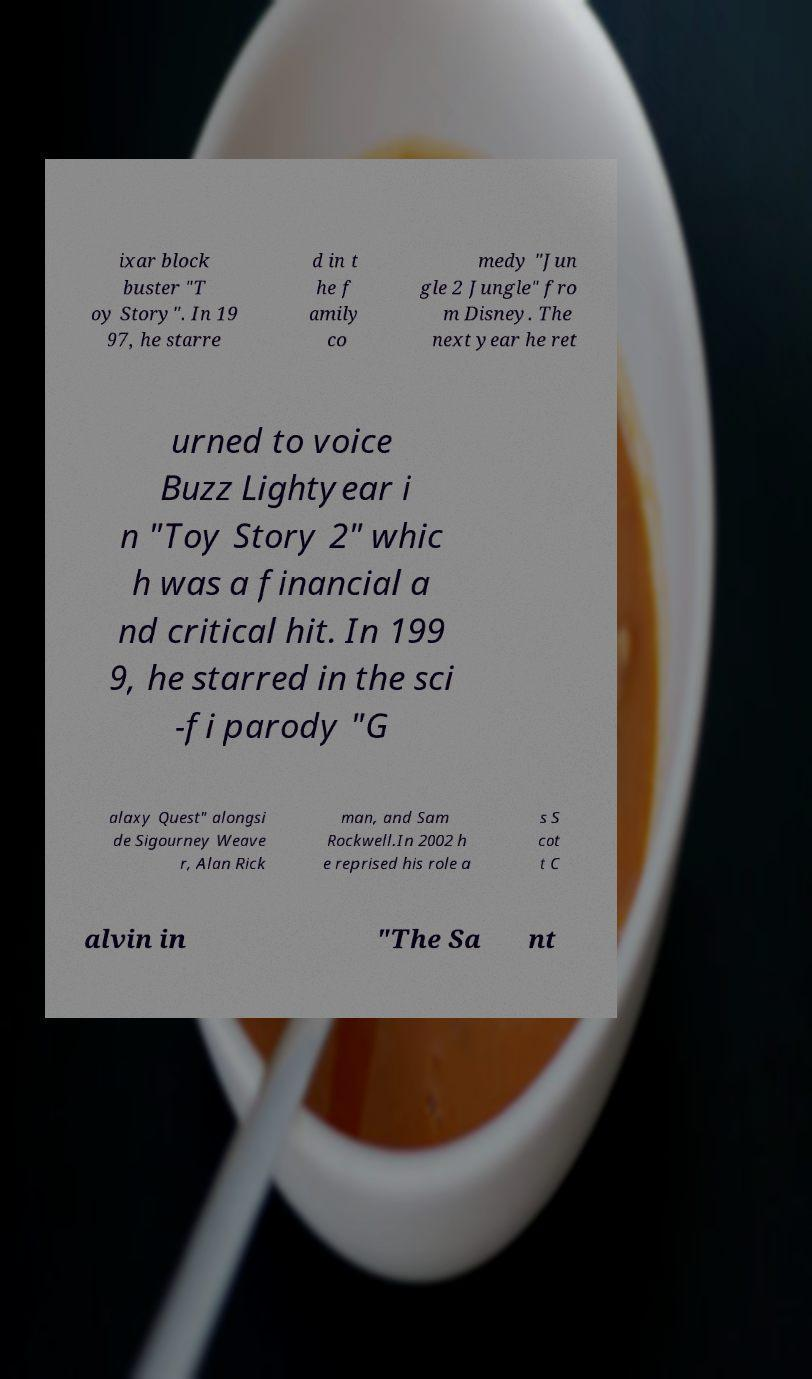Could you assist in decoding the text presented in this image and type it out clearly? ixar block buster "T oy Story". In 19 97, he starre d in t he f amily co medy "Jun gle 2 Jungle" fro m Disney. The next year he ret urned to voice Buzz Lightyear i n "Toy Story 2" whic h was a financial a nd critical hit. In 199 9, he starred in the sci -fi parody "G alaxy Quest" alongsi de Sigourney Weave r, Alan Rick man, and Sam Rockwell.In 2002 h e reprised his role a s S cot t C alvin in "The Sa nt 